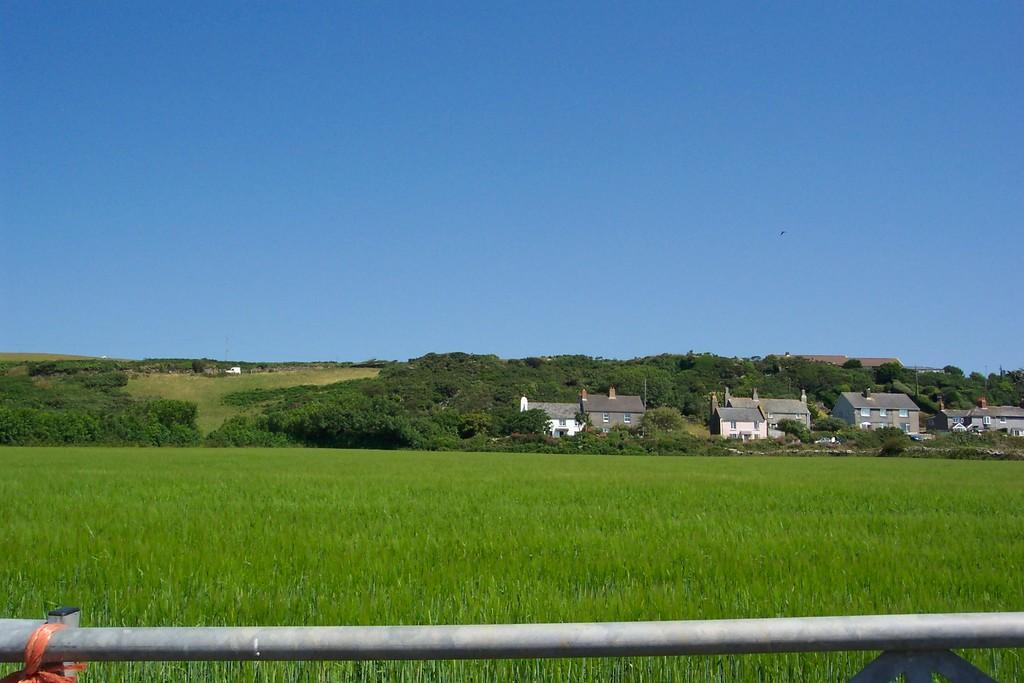Describe this image in one or two sentences. In this image I can see plants, trees, buildings and a rod. In the background I can see the sky. 